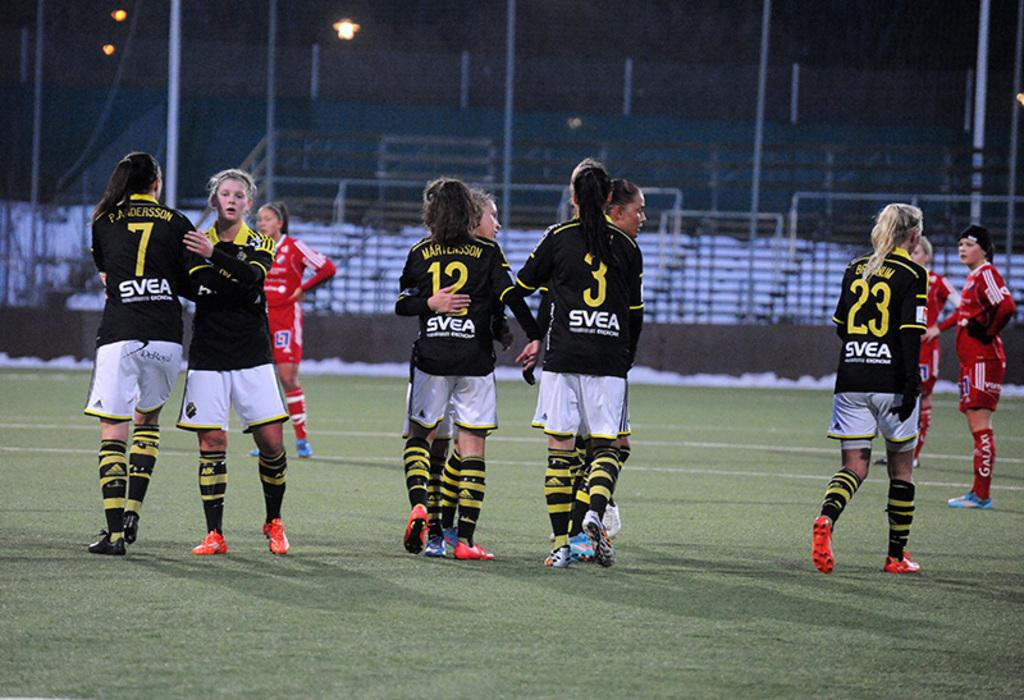<image>
Render a clear and concise summary of the photo. A group of soccor players with number 23 walking to the right. 